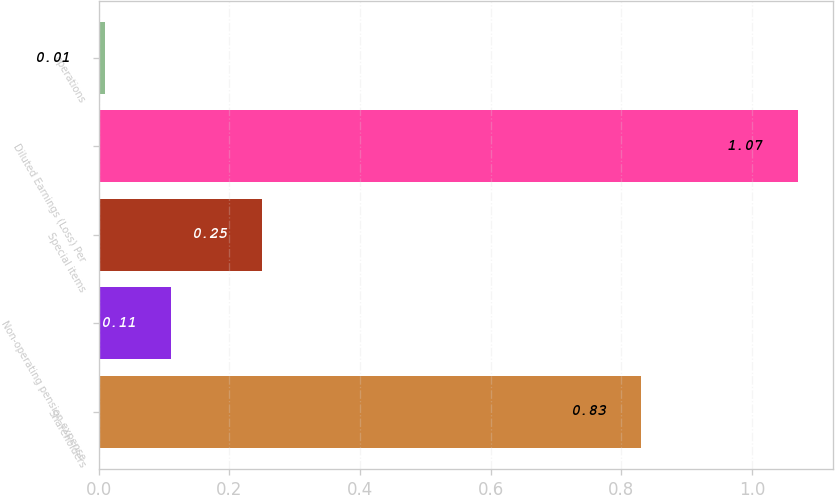Convert chart to OTSL. <chart><loc_0><loc_0><loc_500><loc_500><bar_chart><fcel>Shareholders<fcel>Non-operating pension expense<fcel>Special items<fcel>Diluted Earnings (Loss) Per<fcel>operations<nl><fcel>0.83<fcel>0.11<fcel>0.25<fcel>1.07<fcel>0.01<nl></chart> 